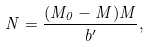<formula> <loc_0><loc_0><loc_500><loc_500>N = \frac { ( M _ { 0 } - M ) M } { b ^ { \prime } } ,</formula> 